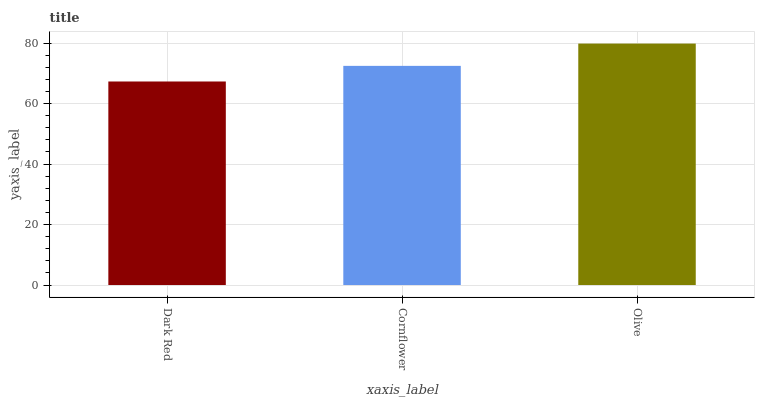Is Dark Red the minimum?
Answer yes or no. Yes. Is Olive the maximum?
Answer yes or no. Yes. Is Cornflower the minimum?
Answer yes or no. No. Is Cornflower the maximum?
Answer yes or no. No. Is Cornflower greater than Dark Red?
Answer yes or no. Yes. Is Dark Red less than Cornflower?
Answer yes or no. Yes. Is Dark Red greater than Cornflower?
Answer yes or no. No. Is Cornflower less than Dark Red?
Answer yes or no. No. Is Cornflower the high median?
Answer yes or no. Yes. Is Cornflower the low median?
Answer yes or no. Yes. Is Dark Red the high median?
Answer yes or no. No. Is Dark Red the low median?
Answer yes or no. No. 